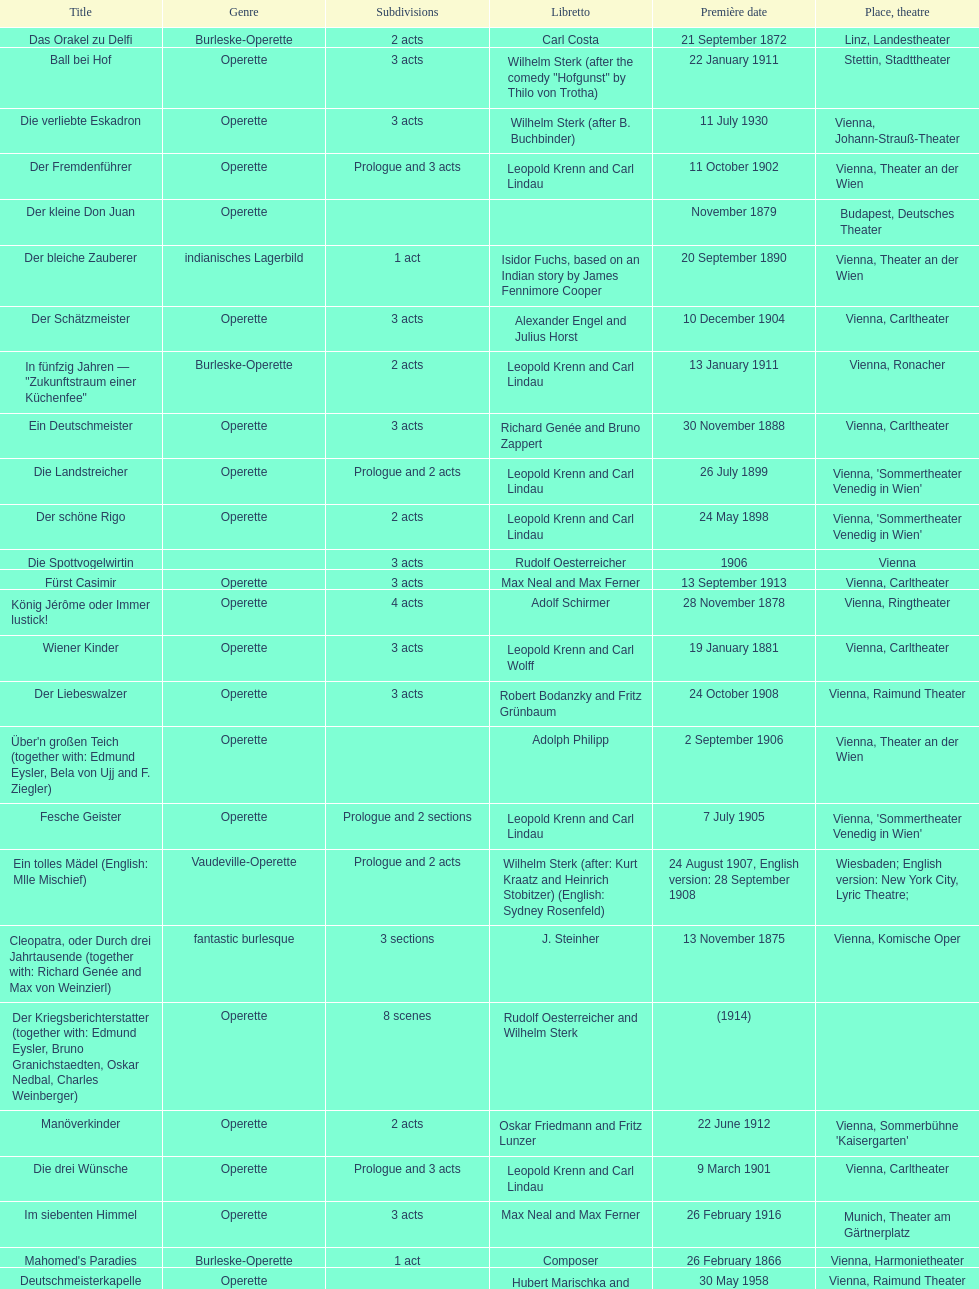What are the number of titles that premiered in the month of september? 4. 